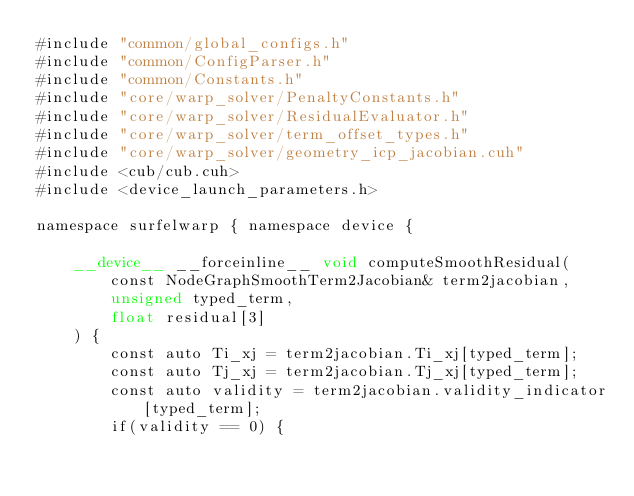Convert code to text. <code><loc_0><loc_0><loc_500><loc_500><_Cuda_>#include "common/global_configs.h"
#include "common/ConfigParser.h"
#include "common/Constants.h"
#include "core/warp_solver/PenaltyConstants.h"
#include "core/warp_solver/ResidualEvaluator.h"
#include "core/warp_solver/term_offset_types.h"
#include "core/warp_solver/geometry_icp_jacobian.cuh"
#include <cub/cub.cuh>
#include <device_launch_parameters.h>

namespace surfelwarp { namespace device {

	__device__ __forceinline__ void computeSmoothResidual(
		const NodeGraphSmoothTerm2Jacobian& term2jacobian,
		unsigned typed_term,
		float residual[3]
	) {
		const auto Ti_xj = term2jacobian.Ti_xj[typed_term];
		const auto Tj_xj = term2jacobian.Tj_xj[typed_term];
		const auto validity = term2jacobian.validity_indicator[typed_term];
		if(validity == 0) {</code> 